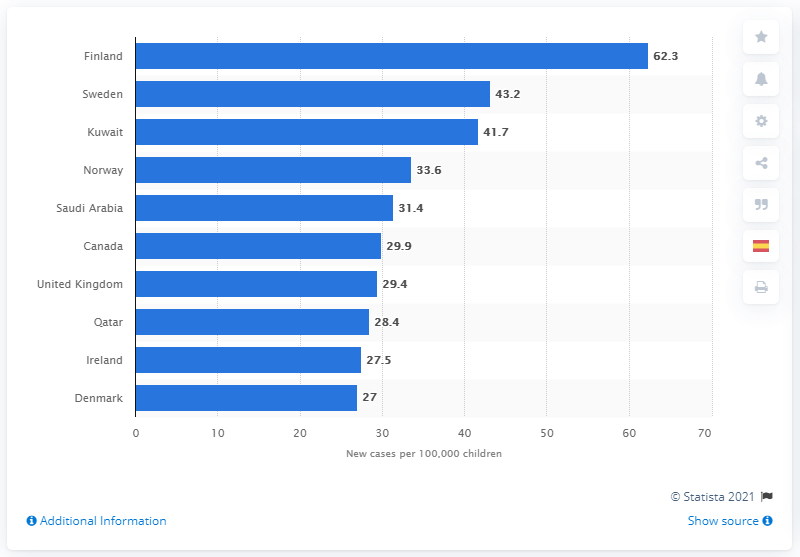Mention a couple of crucial points in this snapshot. According to the data, Finland had the highest rate of new diabetes cases per 100,000 children and adolescents per year compared to the other countries. In Finland, there were an estimated 62.3 new cases of diabetes per 100,000 children and adolescents per year. 